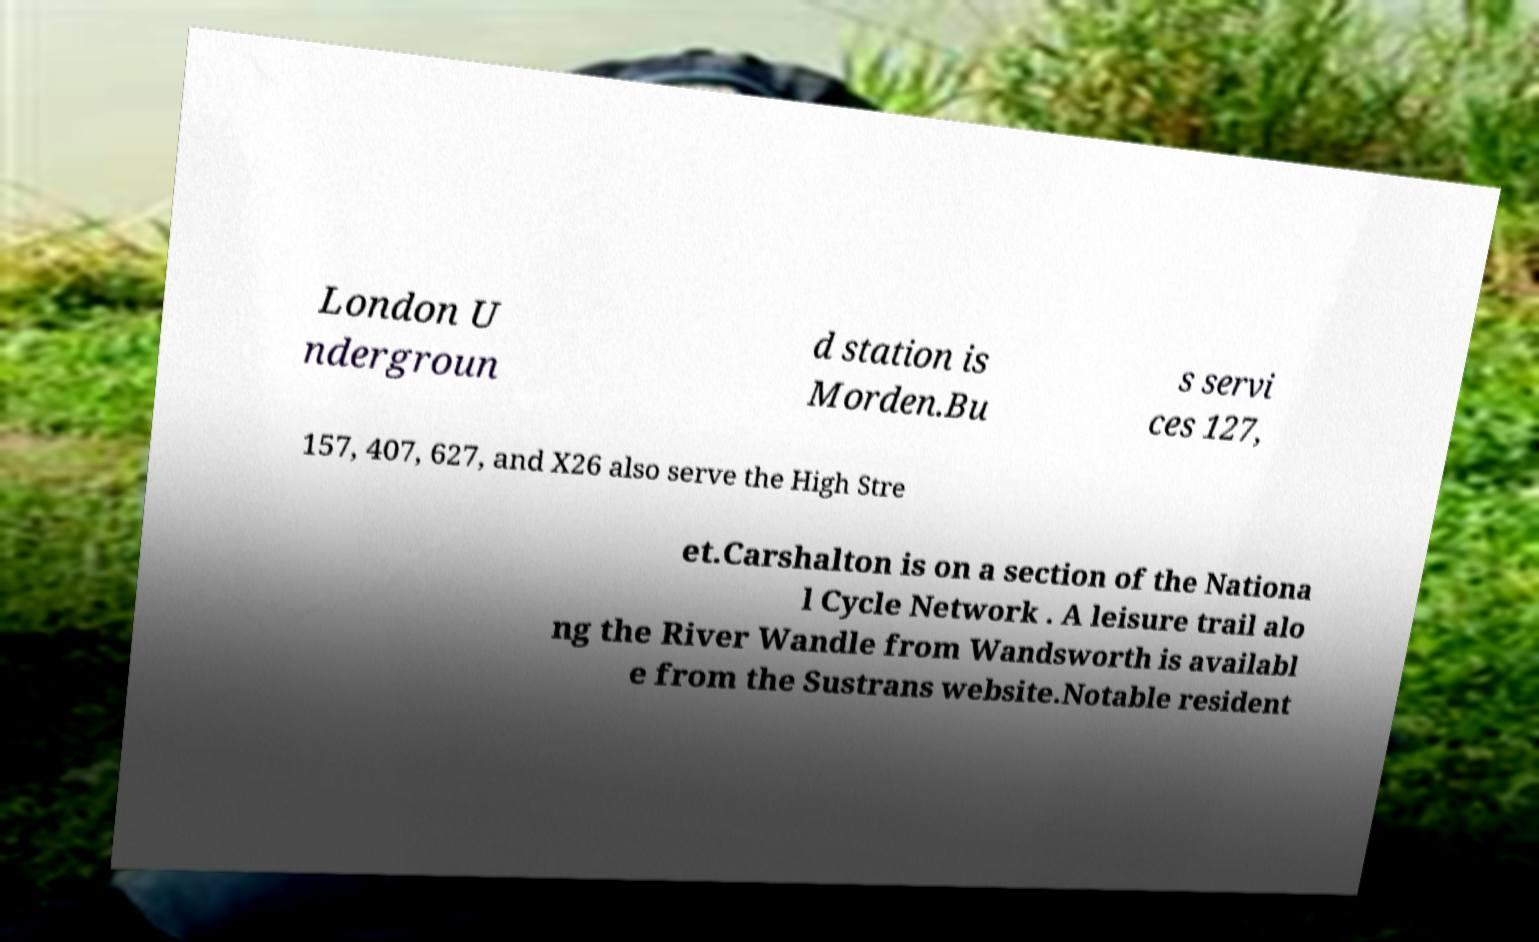Could you assist in decoding the text presented in this image and type it out clearly? London U ndergroun d station is Morden.Bu s servi ces 127, 157, 407, 627, and X26 also serve the High Stre et.Carshalton is on a section of the Nationa l Cycle Network . A leisure trail alo ng the River Wandle from Wandsworth is availabl e from the Sustrans website.Notable resident 